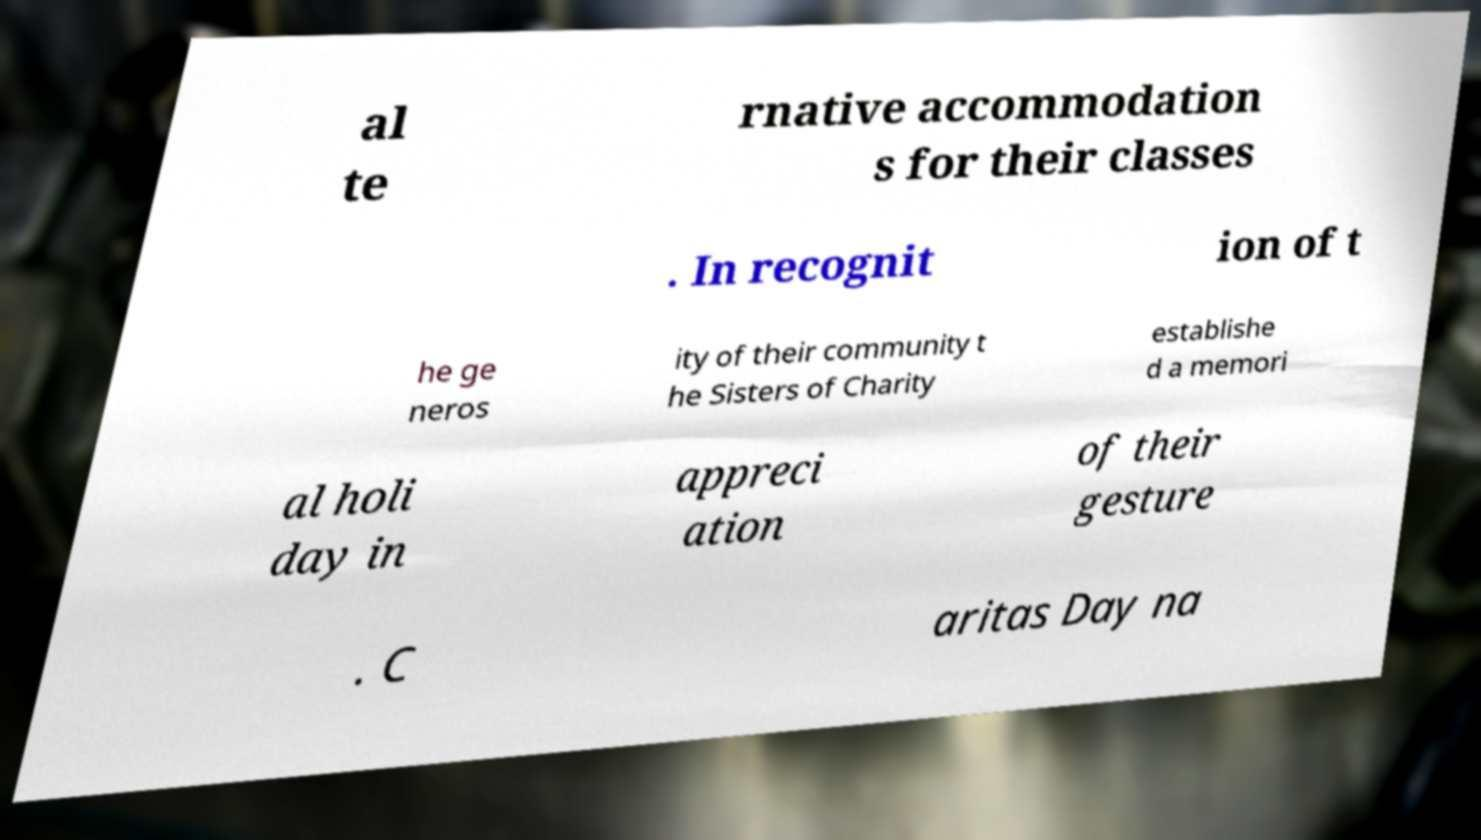For documentation purposes, I need the text within this image transcribed. Could you provide that? al te rnative accommodation s for their classes . In recognit ion of t he ge neros ity of their community t he Sisters of Charity establishe d a memori al holi day in appreci ation of their gesture . C aritas Day na 